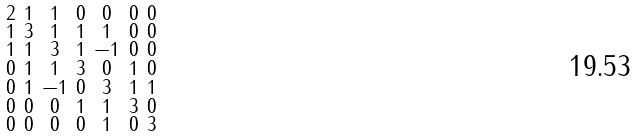<formula> <loc_0><loc_0><loc_500><loc_500>\begin{smallmatrix} 2 & 1 & 1 & 0 & 0 & 0 & 0 \\ 1 & 3 & 1 & 1 & 1 & 0 & 0 \\ 1 & 1 & 3 & 1 & - 1 & 0 & 0 \\ 0 & 1 & 1 & 3 & 0 & 1 & 0 \\ 0 & 1 & - 1 & 0 & 3 & 1 & 1 \\ 0 & 0 & 0 & 1 & 1 & 3 & 0 \\ 0 & 0 & 0 & 0 & 1 & 0 & 3 \end{smallmatrix}</formula> 